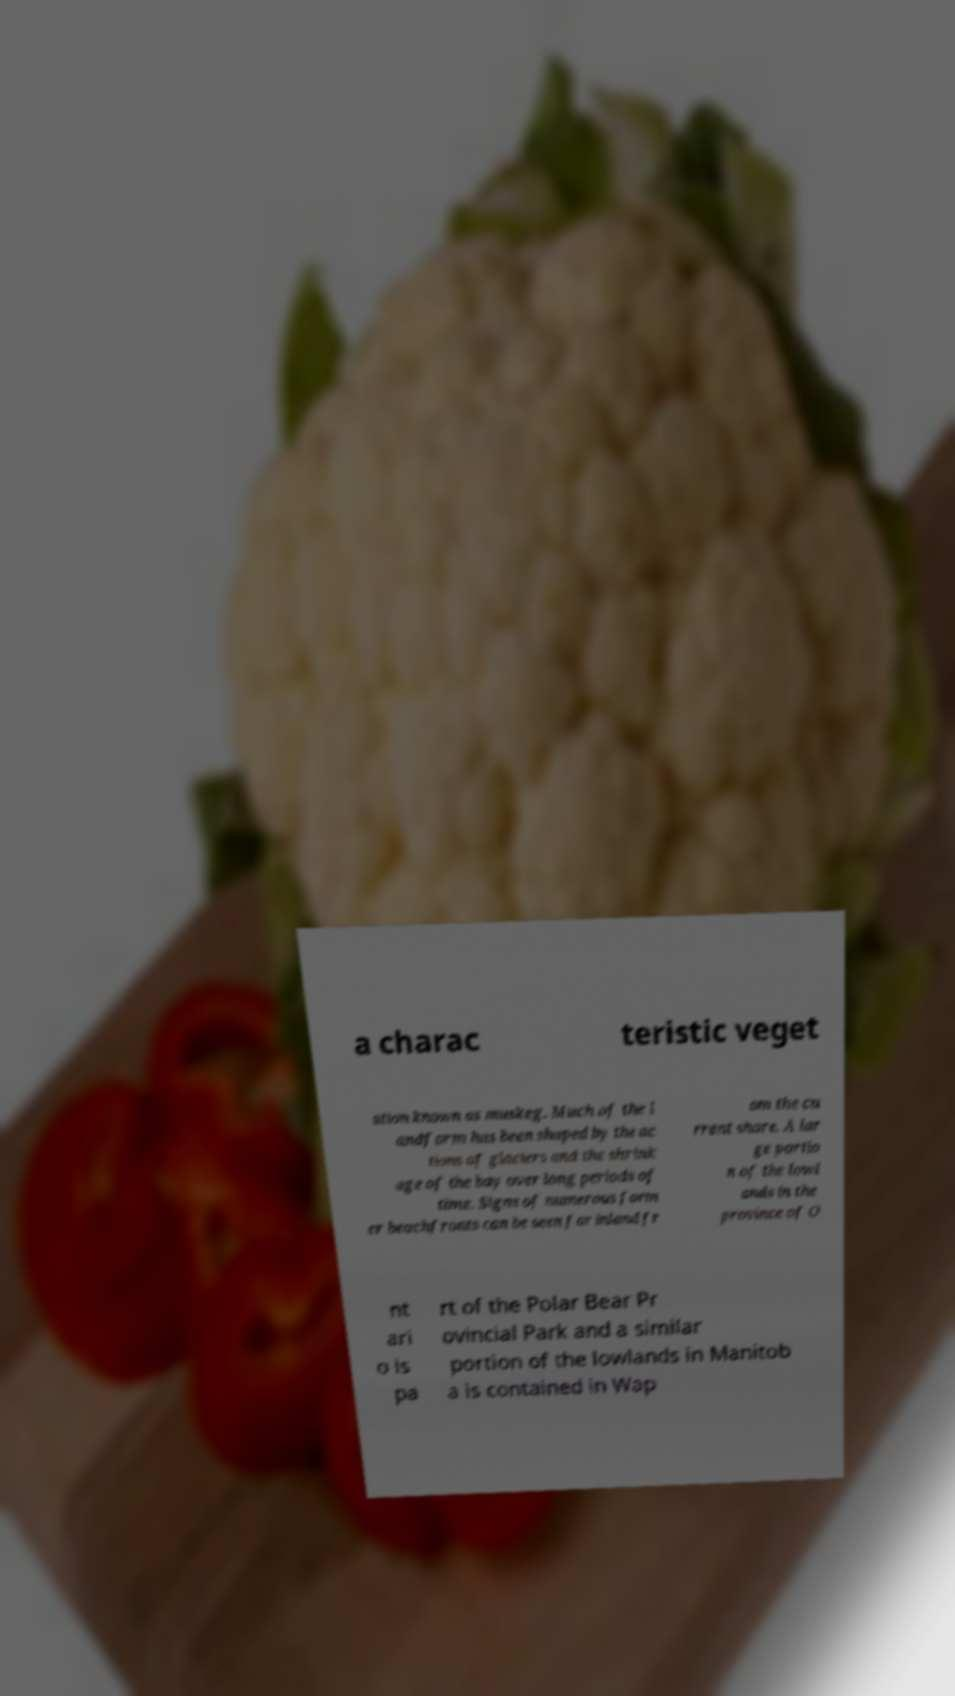There's text embedded in this image that I need extracted. Can you transcribe it verbatim? a charac teristic veget ation known as muskeg. Much of the l andform has been shaped by the ac tions of glaciers and the shrink age of the bay over long periods of time. Signs of numerous form er beachfronts can be seen far inland fr om the cu rrent shore. A lar ge portio n of the lowl ands in the province of O nt ari o is pa rt of the Polar Bear Pr ovincial Park and a similar portion of the lowlands in Manitob a is contained in Wap 